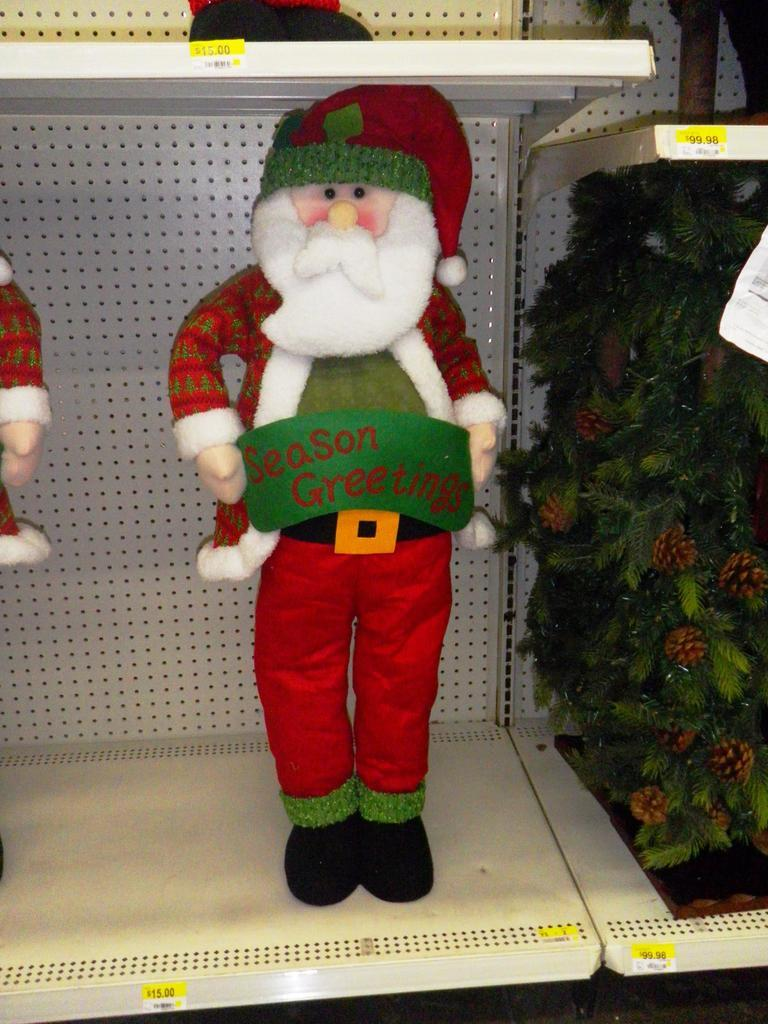<image>
Present a compact description of the photo's key features. A Santa decoration holds a banner that reads "Season greetings." 